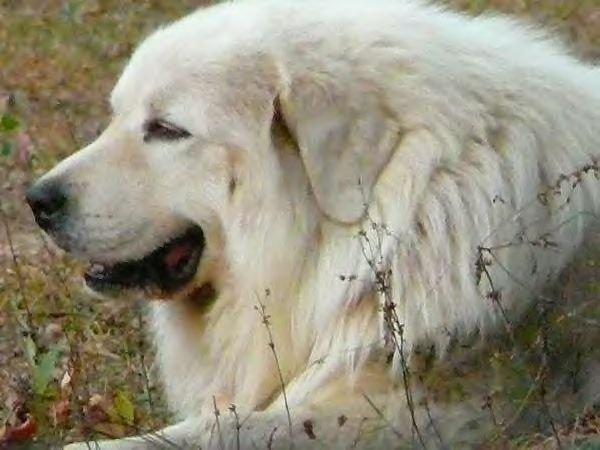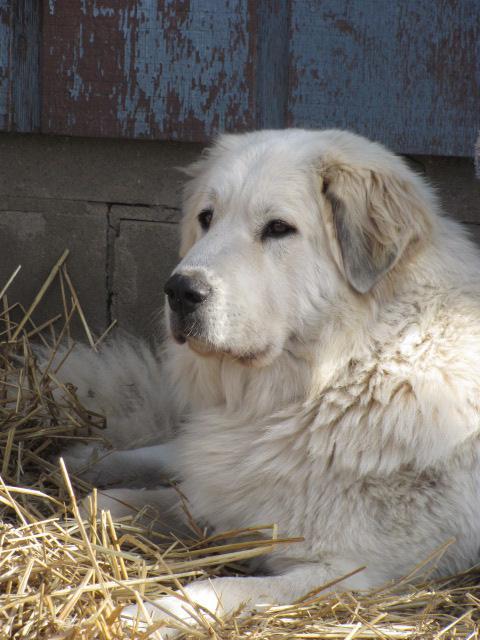The first image is the image on the left, the second image is the image on the right. Examine the images to the left and right. Is the description "There is a lone dog facing the camera in one image and a dog with at least one puppy in the other image." accurate? Answer yes or no. No. The first image is the image on the left, the second image is the image on the right. Examine the images to the left and right. Is the description "Every image contains only one dog" accurate? Answer yes or no. Yes. 